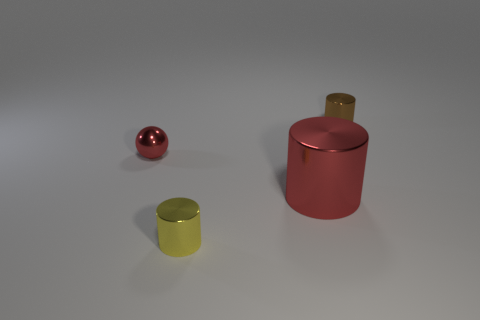There is a brown thing that is right of the large red metal thing; does it have the same shape as the small object that is left of the small yellow metal object?
Your response must be concise. No. Is the number of brown cylinders left of the small yellow cylinder the same as the number of yellow cylinders that are right of the large red metal cylinder?
Give a very brief answer. Yes. What shape is the object that is left of the small cylinder that is to the left of the metal cylinder that is behind the large red metallic cylinder?
Offer a very short reply. Sphere. Is the small cylinder in front of the red metallic sphere made of the same material as the red object that is on the right side of the tiny red metal ball?
Your answer should be compact. Yes. There is a object behind the small metal sphere; what shape is it?
Your answer should be very brief. Cylinder. Are there fewer small green rubber things than tiny metallic objects?
Your answer should be compact. Yes. Are there any red metal things to the right of the small metal cylinder that is in front of the tiny shiny cylinder behind the yellow shiny object?
Provide a succinct answer. Yes. What number of matte objects are either green cylinders or yellow objects?
Offer a terse response. 0. Do the big object and the tiny sphere have the same color?
Offer a very short reply. Yes. What number of big metal objects are on the left side of the red metal cylinder?
Your answer should be compact. 0. 